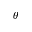<formula> <loc_0><loc_0><loc_500><loc_500>\theta</formula> 